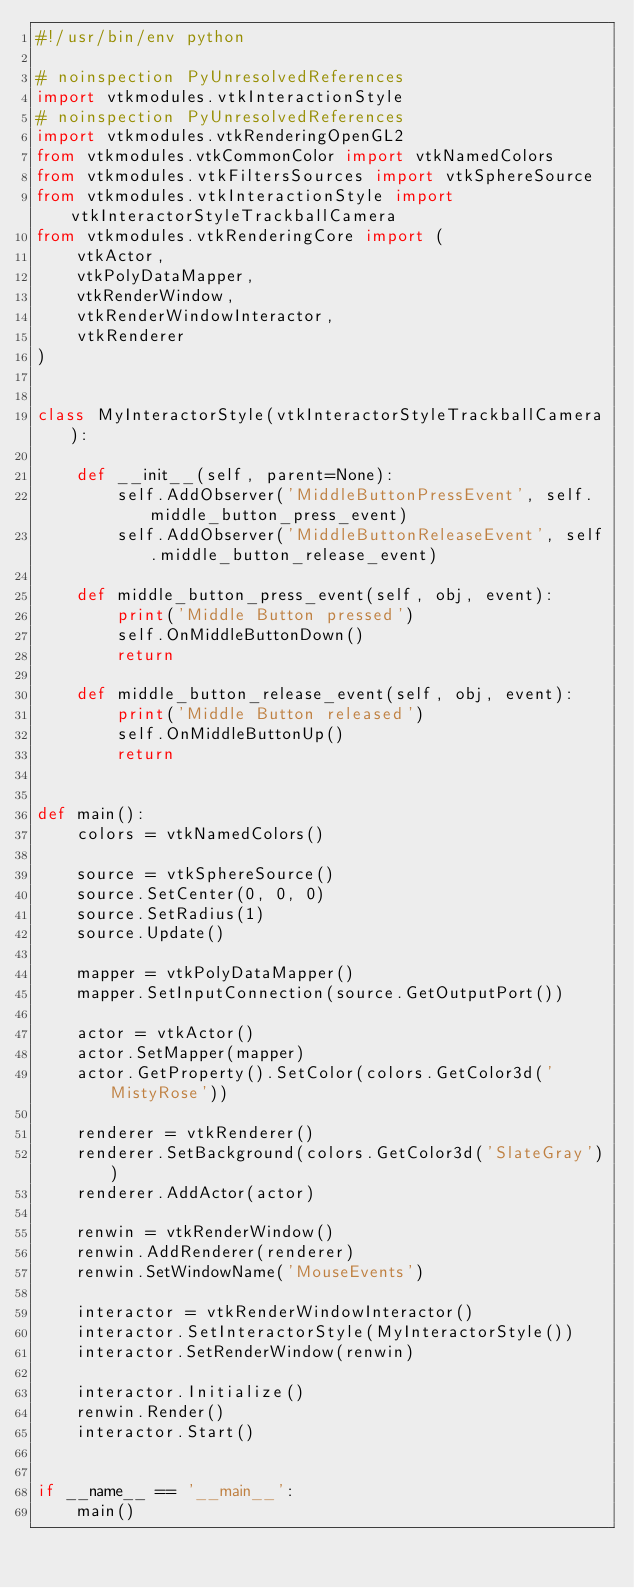Convert code to text. <code><loc_0><loc_0><loc_500><loc_500><_Python_>#!/usr/bin/env python

# noinspection PyUnresolvedReferences
import vtkmodules.vtkInteractionStyle
# noinspection PyUnresolvedReferences
import vtkmodules.vtkRenderingOpenGL2
from vtkmodules.vtkCommonColor import vtkNamedColors
from vtkmodules.vtkFiltersSources import vtkSphereSource
from vtkmodules.vtkInteractionStyle import vtkInteractorStyleTrackballCamera
from vtkmodules.vtkRenderingCore import (
    vtkActor,
    vtkPolyDataMapper,
    vtkRenderWindow,
    vtkRenderWindowInteractor,
    vtkRenderer
)


class MyInteractorStyle(vtkInteractorStyleTrackballCamera):

    def __init__(self, parent=None):
        self.AddObserver('MiddleButtonPressEvent', self.middle_button_press_event)
        self.AddObserver('MiddleButtonReleaseEvent', self.middle_button_release_event)

    def middle_button_press_event(self, obj, event):
        print('Middle Button pressed')
        self.OnMiddleButtonDown()
        return

    def middle_button_release_event(self, obj, event):
        print('Middle Button released')
        self.OnMiddleButtonUp()
        return


def main():
    colors = vtkNamedColors()

    source = vtkSphereSource()
    source.SetCenter(0, 0, 0)
    source.SetRadius(1)
    source.Update()

    mapper = vtkPolyDataMapper()
    mapper.SetInputConnection(source.GetOutputPort())

    actor = vtkActor()
    actor.SetMapper(mapper)
    actor.GetProperty().SetColor(colors.GetColor3d('MistyRose'))

    renderer = vtkRenderer()
    renderer.SetBackground(colors.GetColor3d('SlateGray'))
    renderer.AddActor(actor)

    renwin = vtkRenderWindow()
    renwin.AddRenderer(renderer)
    renwin.SetWindowName('MouseEvents')

    interactor = vtkRenderWindowInteractor()
    interactor.SetInteractorStyle(MyInteractorStyle())
    interactor.SetRenderWindow(renwin)

    interactor.Initialize()
    renwin.Render()
    interactor.Start()


if __name__ == '__main__':
    main()
</code> 